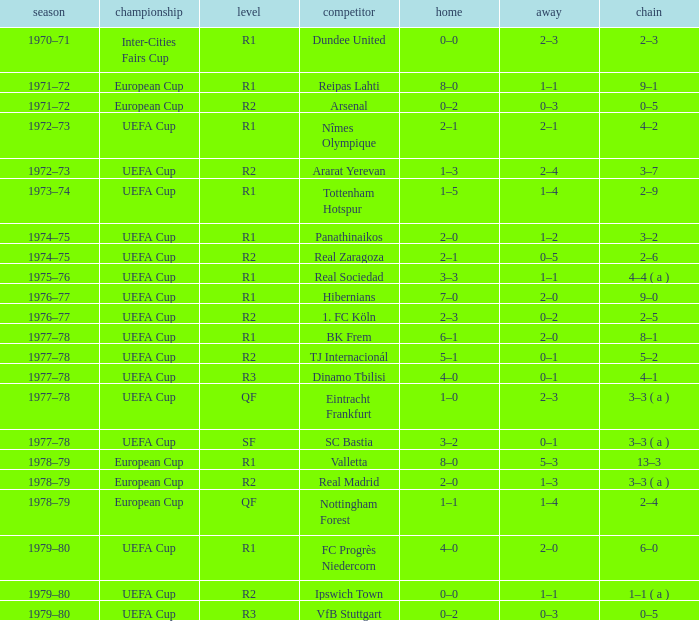Which Season has an Opponent of hibernians? 1976–77. 